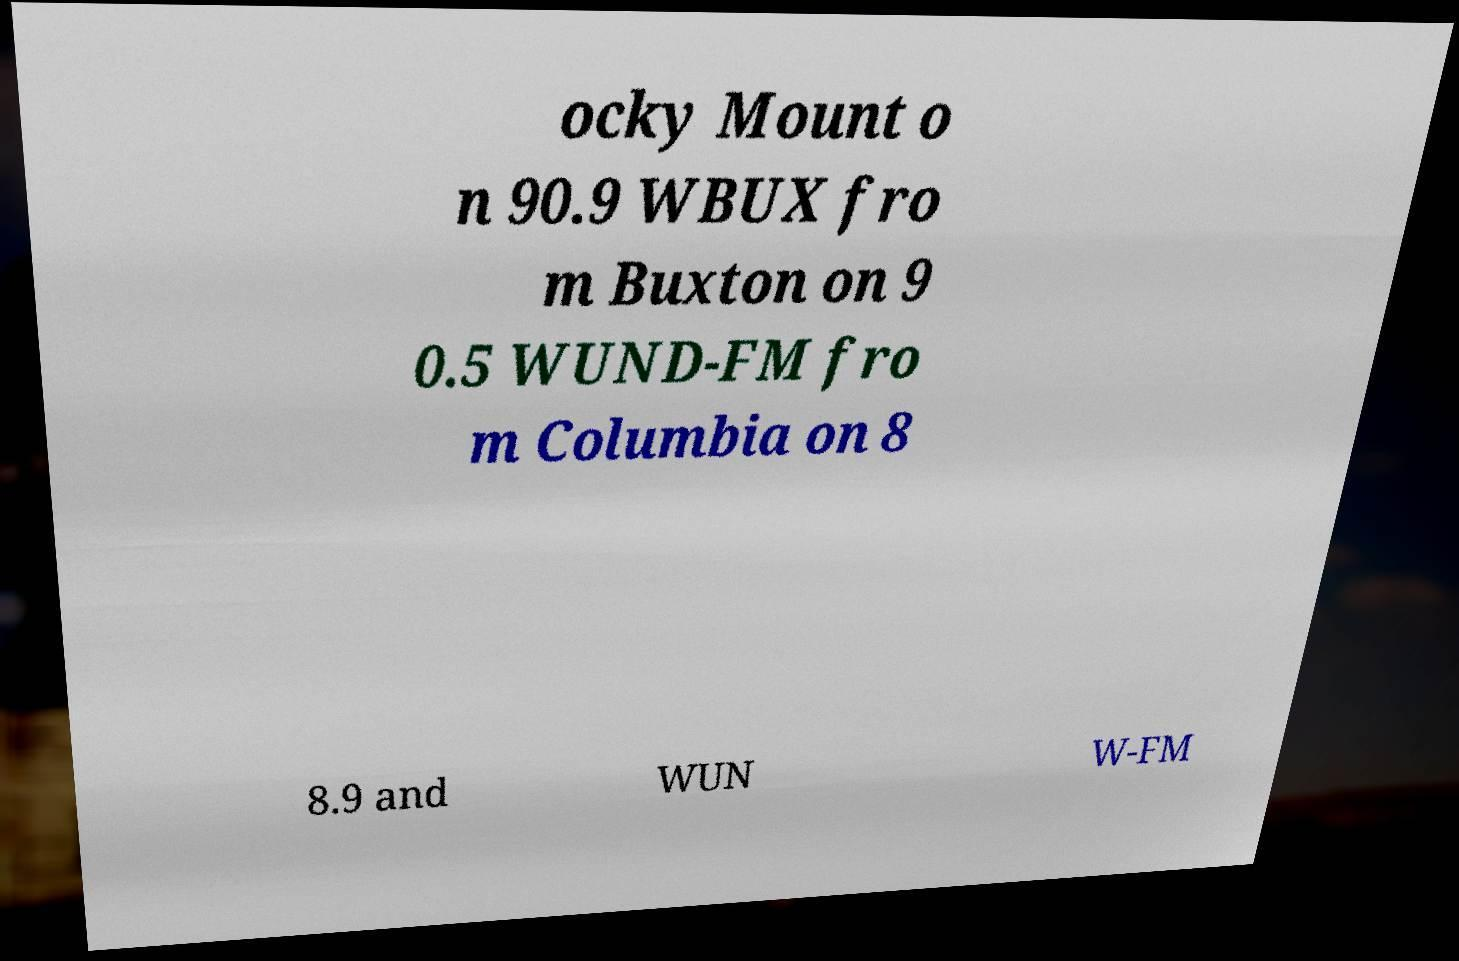Can you accurately transcribe the text from the provided image for me? ocky Mount o n 90.9 WBUX fro m Buxton on 9 0.5 WUND-FM fro m Columbia on 8 8.9 and WUN W-FM 